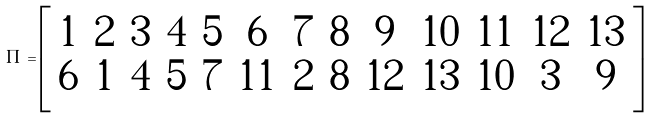Convert formula to latex. <formula><loc_0><loc_0><loc_500><loc_500>\Pi = \left [ \begin{array} { c c c c c c c c c c c c c } 1 & 2 & 3 & 4 & 5 & 6 & 7 & 8 & 9 & 1 0 & 1 1 & 1 2 & 1 3 \\ 6 & 1 & 4 & 5 & 7 & 1 1 & 2 & 8 & 1 2 & 1 3 & 1 0 & 3 & 9 \end{array} \right ]</formula> 